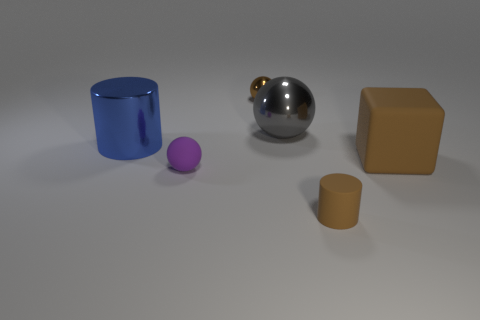Subtract all small metal balls. How many balls are left? 2 Add 3 metallic things. How many objects exist? 9 Subtract all brown cylinders. How many cylinders are left? 1 Subtract all cylinders. How many objects are left? 4 Subtract 1 balls. How many balls are left? 2 Subtract all red balls. Subtract all cyan cylinders. How many balls are left? 3 Subtract all brown cylinders. How many gray spheres are left? 1 Subtract all tiny green matte blocks. Subtract all small brown metallic balls. How many objects are left? 5 Add 4 tiny matte things. How many tiny matte things are left? 6 Add 5 yellow cubes. How many yellow cubes exist? 5 